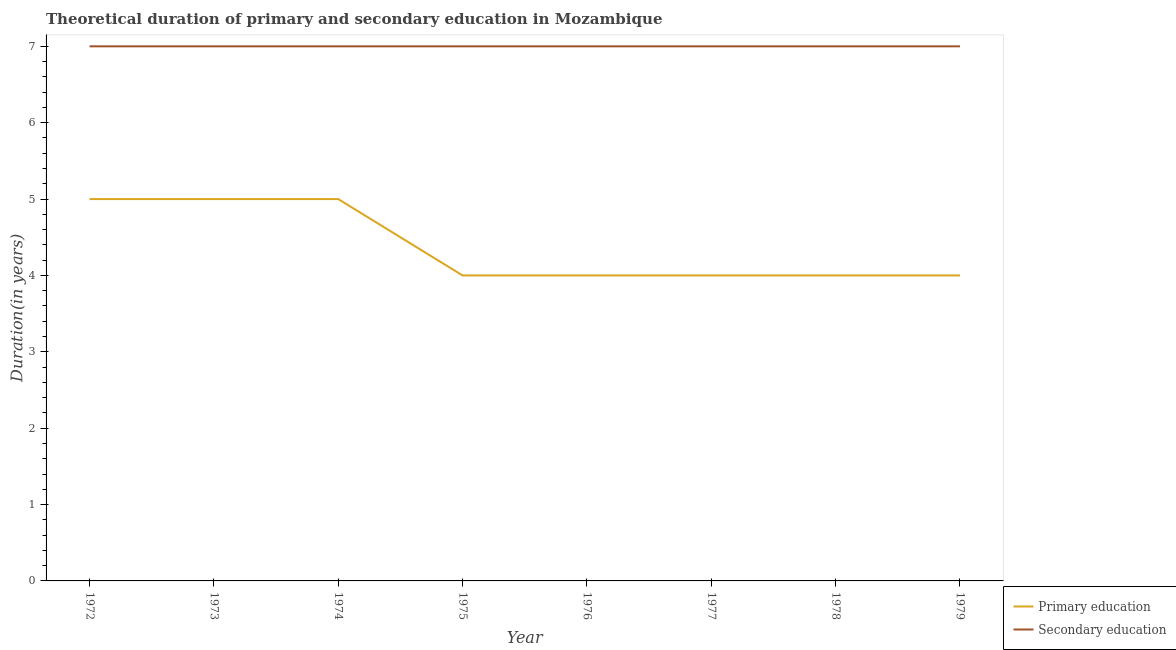How many different coloured lines are there?
Offer a very short reply. 2. Is the number of lines equal to the number of legend labels?
Your response must be concise. Yes. What is the duration of primary education in 1972?
Your answer should be very brief. 5. Across all years, what is the maximum duration of secondary education?
Your response must be concise. 7. Across all years, what is the minimum duration of secondary education?
Ensure brevity in your answer.  7. In which year was the duration of primary education maximum?
Your response must be concise. 1972. In which year was the duration of secondary education minimum?
Offer a very short reply. 1972. What is the total duration of secondary education in the graph?
Make the answer very short. 56. What is the difference between the duration of secondary education in 1979 and the duration of primary education in 1972?
Ensure brevity in your answer.  2. In the year 1973, what is the difference between the duration of secondary education and duration of primary education?
Offer a terse response. 2. What is the ratio of the duration of primary education in 1973 to that in 1977?
Offer a terse response. 1.25. Is the duration of secondary education in 1972 less than that in 1977?
Make the answer very short. No. What is the difference between the highest and the second highest duration of secondary education?
Offer a terse response. 0. Does the duration of primary education monotonically increase over the years?
Offer a very short reply. No. Is the duration of secondary education strictly greater than the duration of primary education over the years?
Your answer should be very brief. Yes. Is the duration of secondary education strictly less than the duration of primary education over the years?
Your answer should be compact. No. How many lines are there?
Your response must be concise. 2. How many years are there in the graph?
Make the answer very short. 8. What is the difference between two consecutive major ticks on the Y-axis?
Ensure brevity in your answer.  1. Are the values on the major ticks of Y-axis written in scientific E-notation?
Make the answer very short. No. How many legend labels are there?
Offer a terse response. 2. How are the legend labels stacked?
Give a very brief answer. Vertical. What is the title of the graph?
Ensure brevity in your answer.  Theoretical duration of primary and secondary education in Mozambique. Does "ODA received" appear as one of the legend labels in the graph?
Provide a short and direct response. No. What is the label or title of the X-axis?
Offer a terse response. Year. What is the label or title of the Y-axis?
Keep it short and to the point. Duration(in years). What is the Duration(in years) of Primary education in 1972?
Make the answer very short. 5. What is the Duration(in years) of Primary education in 1973?
Provide a short and direct response. 5. What is the Duration(in years) in Secondary education in 1973?
Keep it short and to the point. 7. What is the Duration(in years) of Primary education in 1974?
Offer a terse response. 5. What is the Duration(in years) in Secondary education in 1974?
Your answer should be very brief. 7. What is the Duration(in years) in Primary education in 1975?
Offer a very short reply. 4. What is the Duration(in years) of Primary education in 1976?
Make the answer very short. 4. What is the Duration(in years) of Secondary education in 1976?
Give a very brief answer. 7. What is the Duration(in years) in Primary education in 1977?
Your answer should be compact. 4. What is the Duration(in years) in Primary education in 1978?
Provide a succinct answer. 4. What is the Duration(in years) in Secondary education in 1979?
Keep it short and to the point. 7. Across all years, what is the maximum Duration(in years) of Primary education?
Your response must be concise. 5. Across all years, what is the maximum Duration(in years) of Secondary education?
Offer a terse response. 7. Across all years, what is the minimum Duration(in years) of Primary education?
Ensure brevity in your answer.  4. What is the difference between the Duration(in years) of Primary education in 1972 and that in 1973?
Offer a very short reply. 0. What is the difference between the Duration(in years) of Primary education in 1972 and that in 1974?
Your answer should be very brief. 0. What is the difference between the Duration(in years) of Secondary education in 1972 and that in 1974?
Make the answer very short. 0. What is the difference between the Duration(in years) in Primary education in 1972 and that in 1975?
Your response must be concise. 1. What is the difference between the Duration(in years) in Primary education in 1972 and that in 1977?
Provide a short and direct response. 1. What is the difference between the Duration(in years) of Secondary education in 1972 and that in 1977?
Give a very brief answer. 0. What is the difference between the Duration(in years) of Secondary education in 1972 and that in 1978?
Offer a very short reply. 0. What is the difference between the Duration(in years) in Primary education in 1972 and that in 1979?
Keep it short and to the point. 1. What is the difference between the Duration(in years) in Secondary education in 1972 and that in 1979?
Offer a terse response. 0. What is the difference between the Duration(in years) of Primary education in 1973 and that in 1975?
Offer a terse response. 1. What is the difference between the Duration(in years) in Secondary education in 1973 and that in 1976?
Ensure brevity in your answer.  0. What is the difference between the Duration(in years) of Primary education in 1973 and that in 1977?
Give a very brief answer. 1. What is the difference between the Duration(in years) in Secondary education in 1973 and that in 1977?
Your response must be concise. 0. What is the difference between the Duration(in years) in Secondary education in 1973 and that in 1979?
Your response must be concise. 0. What is the difference between the Duration(in years) in Secondary education in 1974 and that in 1977?
Offer a terse response. 0. What is the difference between the Duration(in years) in Primary education in 1974 and that in 1979?
Your answer should be compact. 1. What is the difference between the Duration(in years) of Primary education in 1975 and that in 1977?
Your answer should be very brief. 0. What is the difference between the Duration(in years) of Primary education in 1976 and that in 1977?
Provide a succinct answer. 0. What is the difference between the Duration(in years) of Secondary education in 1976 and that in 1977?
Keep it short and to the point. 0. What is the difference between the Duration(in years) of Secondary education in 1976 and that in 1979?
Offer a terse response. 0. What is the difference between the Duration(in years) of Primary education in 1977 and that in 1979?
Your answer should be very brief. 0. What is the difference between the Duration(in years) of Primary education in 1978 and that in 1979?
Your answer should be compact. 0. What is the difference between the Duration(in years) of Secondary education in 1978 and that in 1979?
Your answer should be very brief. 0. What is the difference between the Duration(in years) of Primary education in 1972 and the Duration(in years) of Secondary education in 1973?
Your response must be concise. -2. What is the difference between the Duration(in years) of Primary education in 1972 and the Duration(in years) of Secondary education in 1976?
Ensure brevity in your answer.  -2. What is the difference between the Duration(in years) of Primary education in 1972 and the Duration(in years) of Secondary education in 1977?
Provide a succinct answer. -2. What is the difference between the Duration(in years) in Primary education in 1972 and the Duration(in years) in Secondary education in 1979?
Keep it short and to the point. -2. What is the difference between the Duration(in years) in Primary education in 1973 and the Duration(in years) in Secondary education in 1979?
Provide a short and direct response. -2. What is the difference between the Duration(in years) of Primary education in 1974 and the Duration(in years) of Secondary education in 1976?
Your answer should be compact. -2. What is the difference between the Duration(in years) in Primary education in 1974 and the Duration(in years) in Secondary education in 1978?
Give a very brief answer. -2. What is the difference between the Duration(in years) in Primary education in 1974 and the Duration(in years) in Secondary education in 1979?
Your answer should be compact. -2. What is the difference between the Duration(in years) of Primary education in 1975 and the Duration(in years) of Secondary education in 1976?
Your answer should be compact. -3. What is the difference between the Duration(in years) in Primary education in 1976 and the Duration(in years) in Secondary education in 1977?
Give a very brief answer. -3. What is the difference between the Duration(in years) of Primary education in 1976 and the Duration(in years) of Secondary education in 1978?
Make the answer very short. -3. What is the difference between the Duration(in years) in Primary education in 1976 and the Duration(in years) in Secondary education in 1979?
Provide a short and direct response. -3. What is the difference between the Duration(in years) of Primary education in 1977 and the Duration(in years) of Secondary education in 1978?
Your response must be concise. -3. What is the average Duration(in years) of Primary education per year?
Keep it short and to the point. 4.38. What is the average Duration(in years) in Secondary education per year?
Your answer should be compact. 7. In the year 1972, what is the difference between the Duration(in years) of Primary education and Duration(in years) of Secondary education?
Make the answer very short. -2. In the year 1973, what is the difference between the Duration(in years) in Primary education and Duration(in years) in Secondary education?
Provide a succinct answer. -2. In the year 1974, what is the difference between the Duration(in years) of Primary education and Duration(in years) of Secondary education?
Provide a succinct answer. -2. In the year 1975, what is the difference between the Duration(in years) in Primary education and Duration(in years) in Secondary education?
Offer a terse response. -3. In the year 1976, what is the difference between the Duration(in years) of Primary education and Duration(in years) of Secondary education?
Your answer should be compact. -3. In the year 1977, what is the difference between the Duration(in years) in Primary education and Duration(in years) in Secondary education?
Keep it short and to the point. -3. In the year 1979, what is the difference between the Duration(in years) of Primary education and Duration(in years) of Secondary education?
Your answer should be compact. -3. What is the ratio of the Duration(in years) of Secondary education in 1972 to that in 1973?
Make the answer very short. 1. What is the ratio of the Duration(in years) of Primary education in 1972 to that in 1977?
Your answer should be very brief. 1.25. What is the ratio of the Duration(in years) in Primary education in 1972 to that in 1979?
Give a very brief answer. 1.25. What is the ratio of the Duration(in years) in Secondary education in 1972 to that in 1979?
Provide a succinct answer. 1. What is the ratio of the Duration(in years) in Secondary education in 1973 to that in 1974?
Your answer should be compact. 1. What is the ratio of the Duration(in years) in Secondary education in 1973 to that in 1975?
Keep it short and to the point. 1. What is the ratio of the Duration(in years) in Primary education in 1973 to that in 1976?
Your response must be concise. 1.25. What is the ratio of the Duration(in years) in Primary education in 1973 to that in 1977?
Offer a terse response. 1.25. What is the ratio of the Duration(in years) of Primary education in 1973 to that in 1978?
Keep it short and to the point. 1.25. What is the ratio of the Duration(in years) of Secondary education in 1973 to that in 1978?
Ensure brevity in your answer.  1. What is the ratio of the Duration(in years) in Primary education in 1974 to that in 1977?
Make the answer very short. 1.25. What is the ratio of the Duration(in years) in Secondary education in 1974 to that in 1977?
Provide a succinct answer. 1. What is the ratio of the Duration(in years) in Primary education in 1974 to that in 1978?
Keep it short and to the point. 1.25. What is the ratio of the Duration(in years) of Secondary education in 1974 to that in 1978?
Offer a terse response. 1. What is the ratio of the Duration(in years) of Primary education in 1974 to that in 1979?
Your answer should be very brief. 1.25. What is the ratio of the Duration(in years) in Secondary education in 1974 to that in 1979?
Your answer should be compact. 1. What is the ratio of the Duration(in years) of Primary education in 1975 to that in 1976?
Provide a short and direct response. 1. What is the ratio of the Duration(in years) in Primary education in 1975 to that in 1977?
Make the answer very short. 1. What is the ratio of the Duration(in years) in Secondary education in 1975 to that in 1977?
Make the answer very short. 1. What is the ratio of the Duration(in years) in Primary education in 1975 to that in 1978?
Your answer should be compact. 1. What is the ratio of the Duration(in years) of Secondary education in 1975 to that in 1979?
Provide a succinct answer. 1. What is the ratio of the Duration(in years) of Primary education in 1976 to that in 1978?
Ensure brevity in your answer.  1. What is the ratio of the Duration(in years) in Secondary education in 1976 to that in 1978?
Your response must be concise. 1. What is the ratio of the Duration(in years) of Secondary education in 1976 to that in 1979?
Offer a terse response. 1. What is the ratio of the Duration(in years) of Secondary education in 1977 to that in 1978?
Ensure brevity in your answer.  1. What is the ratio of the Duration(in years) in Primary education in 1977 to that in 1979?
Provide a short and direct response. 1. What is the ratio of the Duration(in years) in Secondary education in 1977 to that in 1979?
Provide a succinct answer. 1. What is the ratio of the Duration(in years) in Secondary education in 1978 to that in 1979?
Your answer should be compact. 1. What is the difference between the highest and the second highest Duration(in years) of Secondary education?
Give a very brief answer. 0. What is the difference between the highest and the lowest Duration(in years) of Secondary education?
Offer a terse response. 0. 